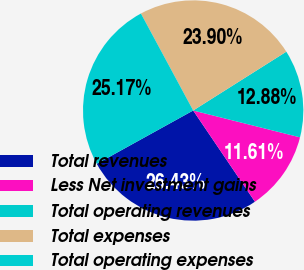Convert chart. <chart><loc_0><loc_0><loc_500><loc_500><pie_chart><fcel>Total revenues<fcel>Less Net investment gains<fcel>Total operating revenues<fcel>Total expenses<fcel>Total operating expenses<nl><fcel>26.43%<fcel>11.61%<fcel>12.88%<fcel>23.9%<fcel>25.17%<nl></chart> 